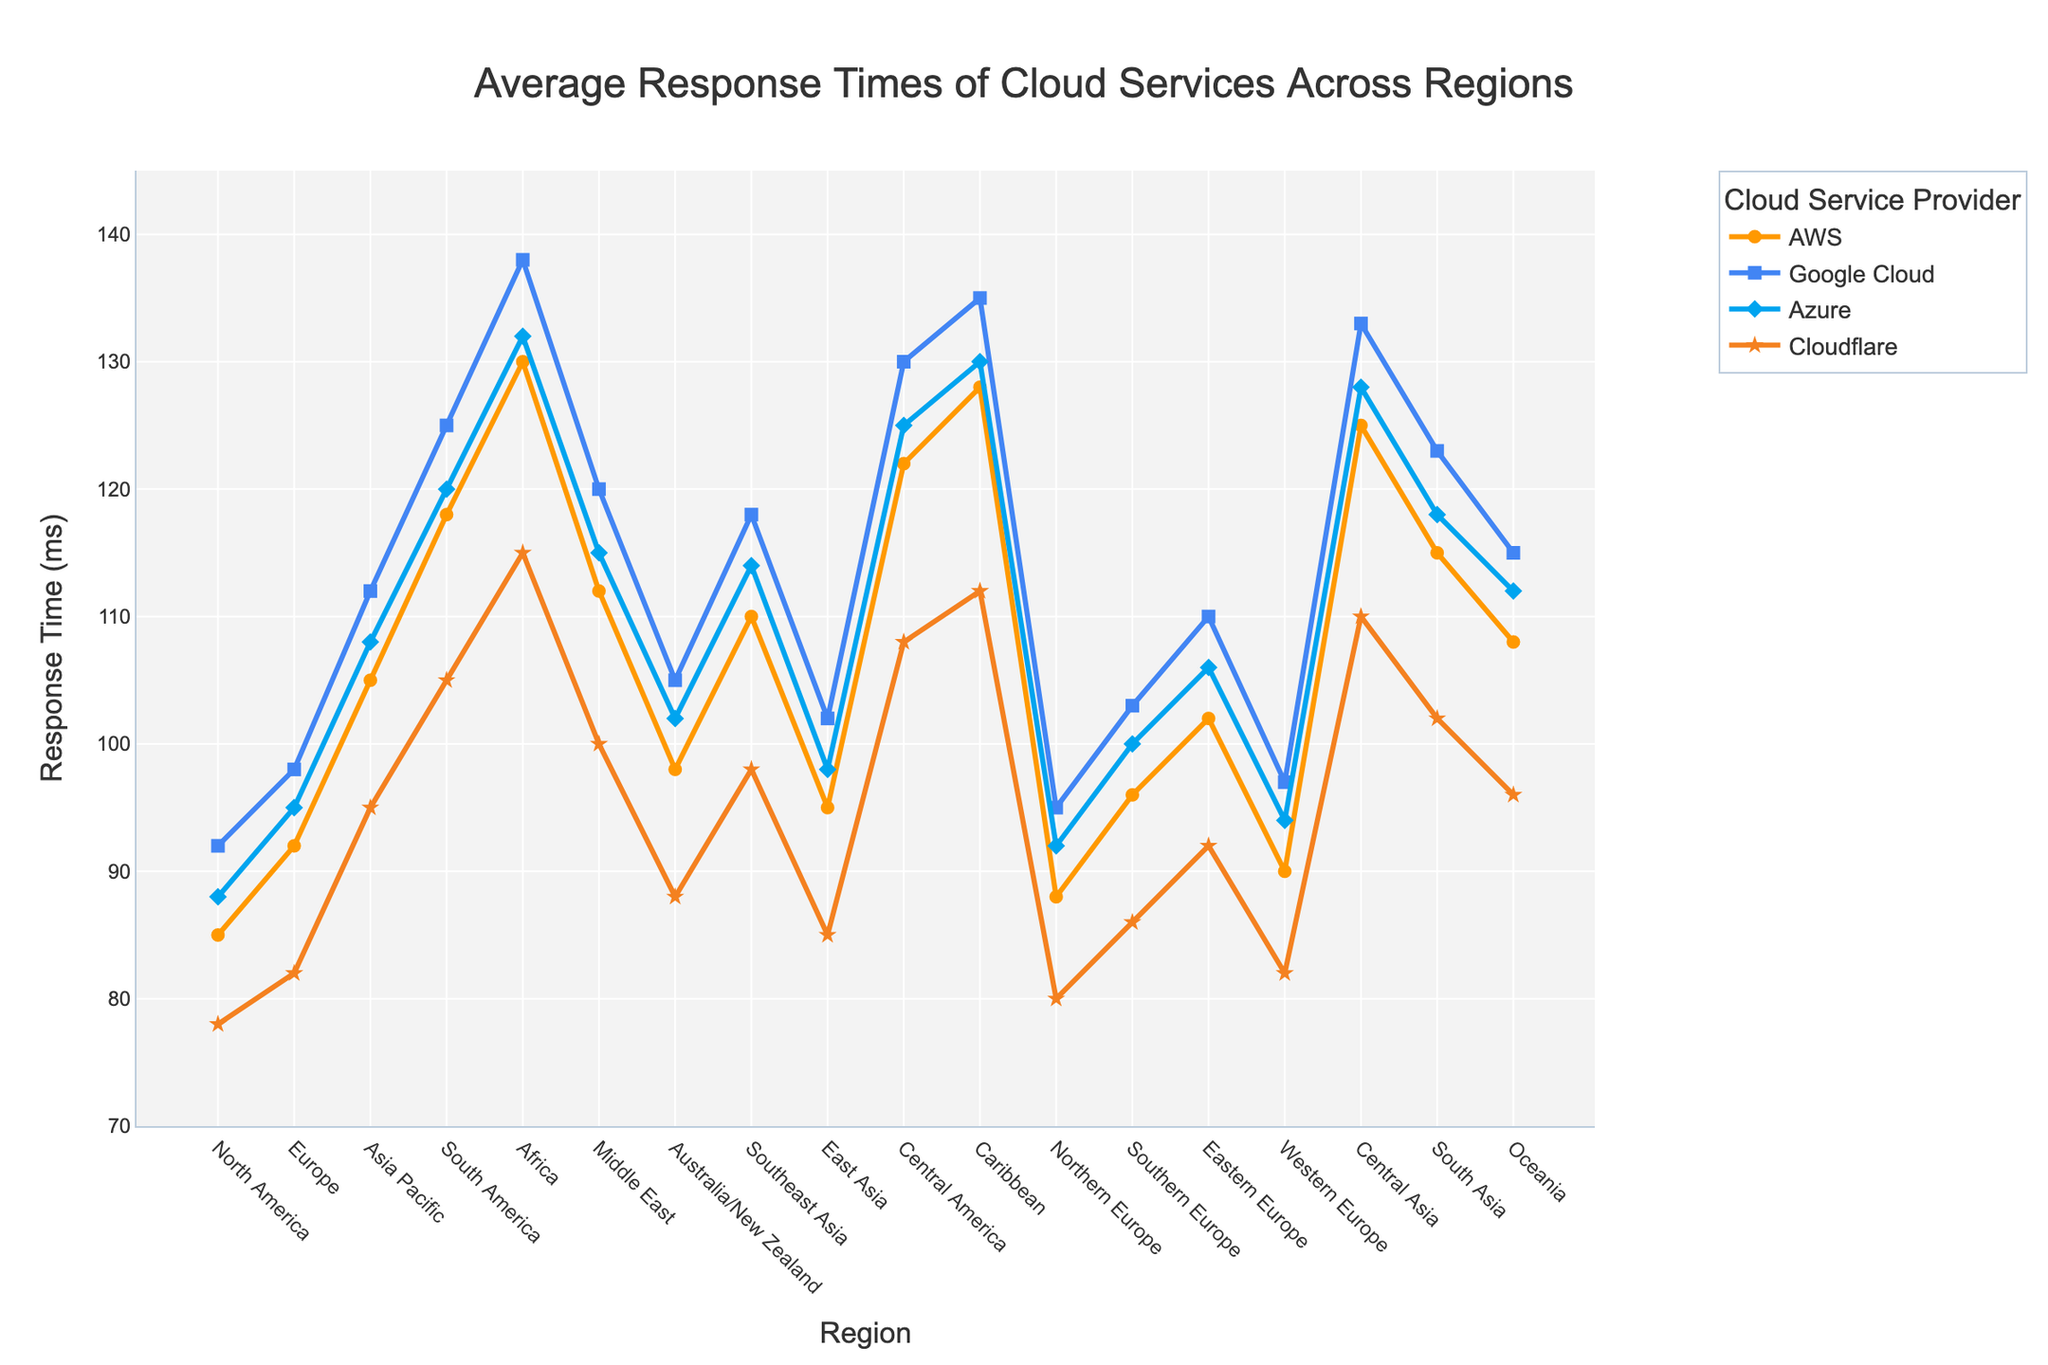What's the region with the highest average response time for AWS services? By visually comparing the line corresponding to AWS services (orange line) across different regions, the highest point on this line appears above the "Africa" region. Therefore, Africa has the highest average response time for AWS services.
Answer: Africa Which cloud service provider has the lowest response time in Northern Europe? Looking at the lines above the "Northern Europe" region, the lowest point is on the line representing Cloudflare (orange line), indicating that Cloudflare has the lowest response time in Northern Europe.
Answer: Cloudflare How does the response time for Azure in Southeast Asia compare to Azure in East Asia? By comparing the line corresponding to Azure services (blue line) above the "Southeast Asia" and "East Asia" regions, the response time in Southeast Asia is higher (114 ms) than in East Asia (98 ms).
Answer: Southeast Asia has a higher response time than East Asia What is the difference in response times between Cloudflare and AWS in the Middle East? The response time for Cloudflare in the Middle East is 100 ms, and for AWS, it is 112 ms. Subtracting these values gives 112 - 100 = 12 ms.
Answer: 12 ms Which region has the least variation in response times among the four cloud service providers? Examining the extent of the vertical spread of data points in each region reveals that Northern Europe has relatively small differences between response times among different providers (AWS: 88 ms, Google Cloud: 95 ms, Azure: 92 ms, Cloudflare: 80 ms), implying the least variation.
Answer: Northern Europe What's the average response time of all services in Southern Europe? The response times for Southern Europe: AWS (96 ms), Google Cloud (103 ms), Azure (100 ms), Cloudflare (86 ms). Summing these and dividing by 4 gives (96 + 103 + 100 + 86) / 4 = 385 / 4 = 96.25 ms.
Answer: 96.25 ms For the region with the highest response time for Cloudflare, what is the response time difference between Cloudflare and Google Cloud? The highest response time for Cloudflare is in Africa at 115 ms. For the same region, the response time for Google Cloud is 138 ms. The difference is 138 - 115 = 23 ms.
Answer: 23 ms In which region do Google Cloud and Azure have the same response time? Scanning the lines corresponding to Google Cloud (blue line) and Azure (light blue line), they intersect only in the "Eastern Europe" region, where both show 110 ms.
Answer: Eastern Europe What’s the average response time for AWS services across Asia Pacific, Middle East, and Southeast Asia? The response times are 105 ms for Asia Pacific, 112 ms for the Middle East, and 110 ms for Southeast Asia. Summing these and dividing by 3 gives (105 + 112 + 110) / 3 = 327 / 3 = 109 ms.
Answer: 109 ms 